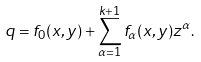Convert formula to latex. <formula><loc_0><loc_0><loc_500><loc_500>q = f _ { 0 } ( x , y ) + \sum _ { \alpha = 1 } ^ { k + 1 } f _ { \alpha } ( x , y ) z ^ { \alpha } .</formula> 